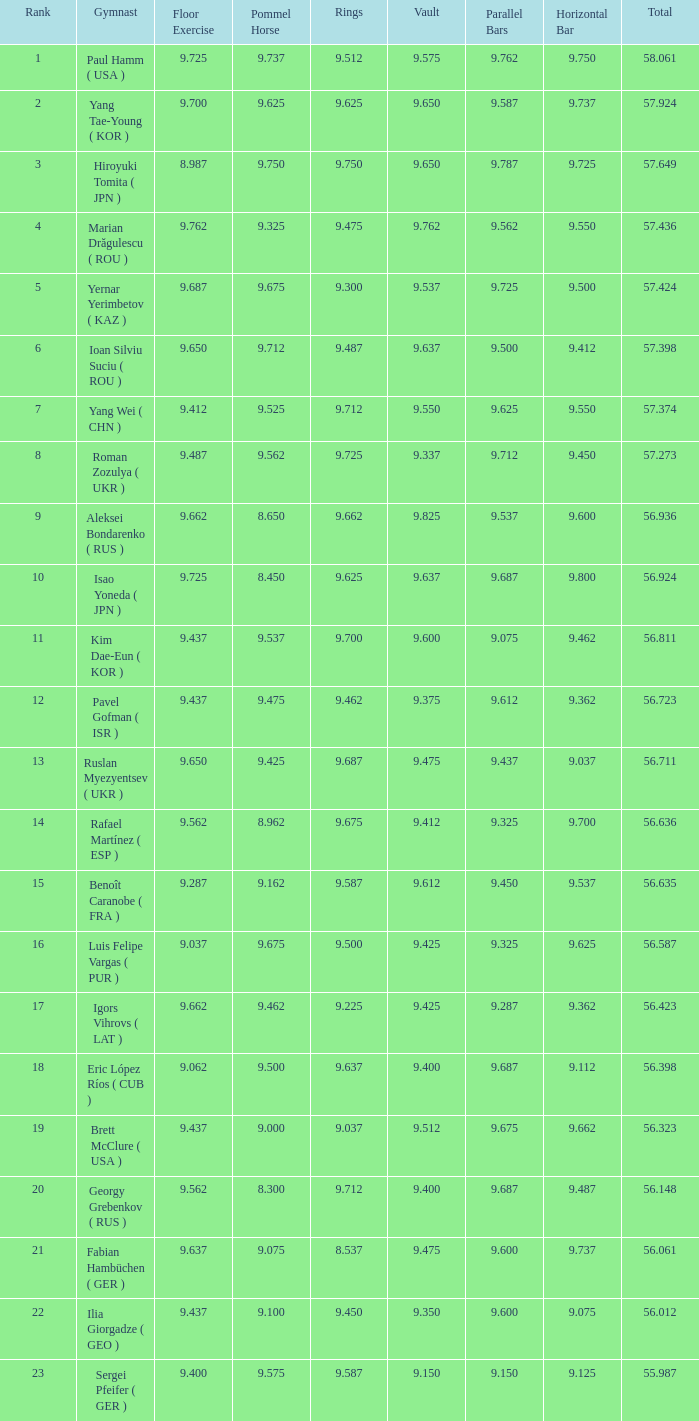When the floor exercise score was 9.287, what was the overall total score? 56.635. 